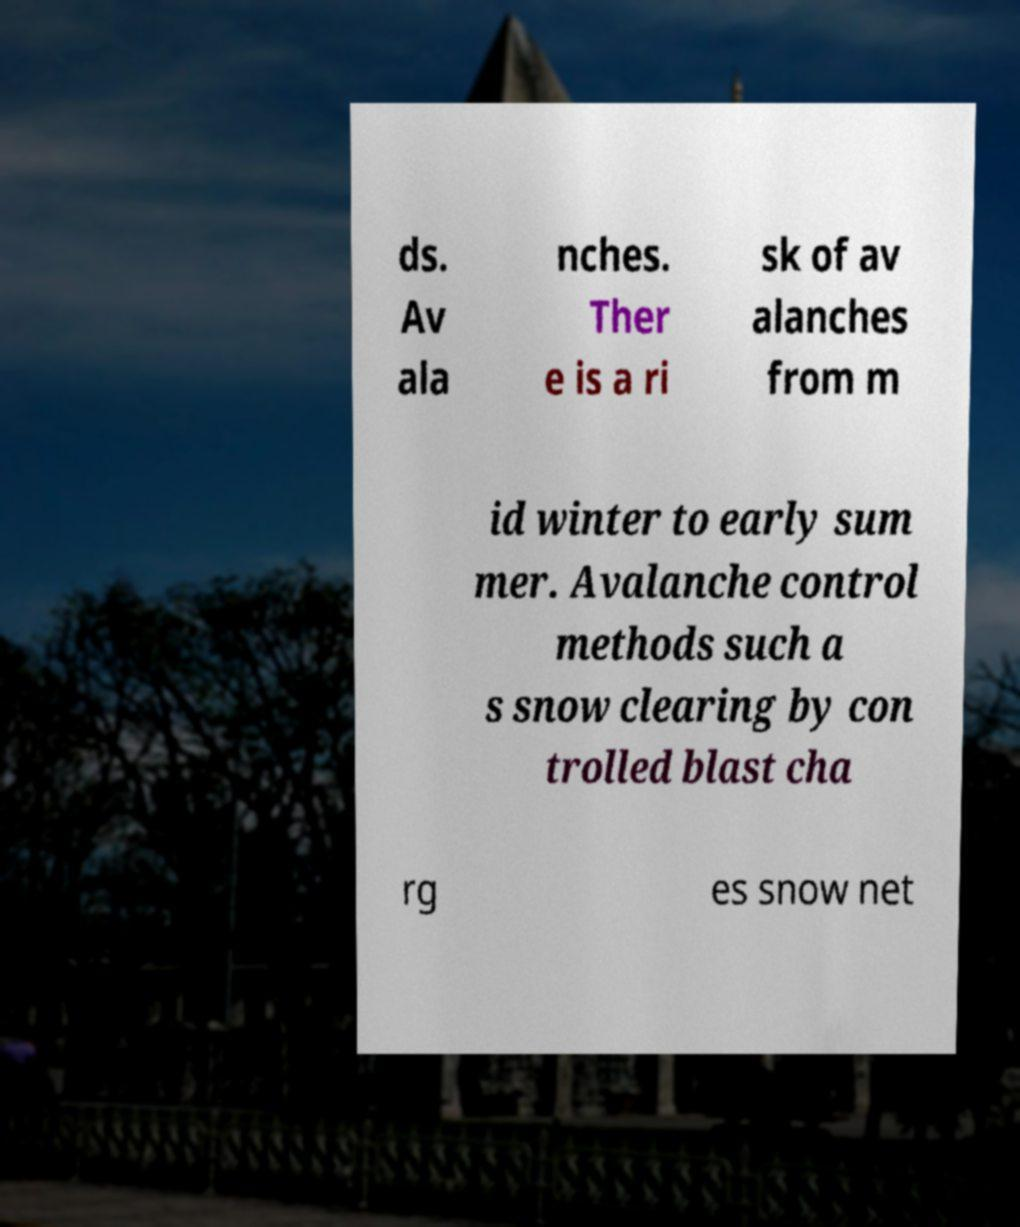Can you accurately transcribe the text from the provided image for me? ds. Av ala nches. Ther e is a ri sk of av alanches from m id winter to early sum mer. Avalanche control methods such a s snow clearing by con trolled blast cha rg es snow net 